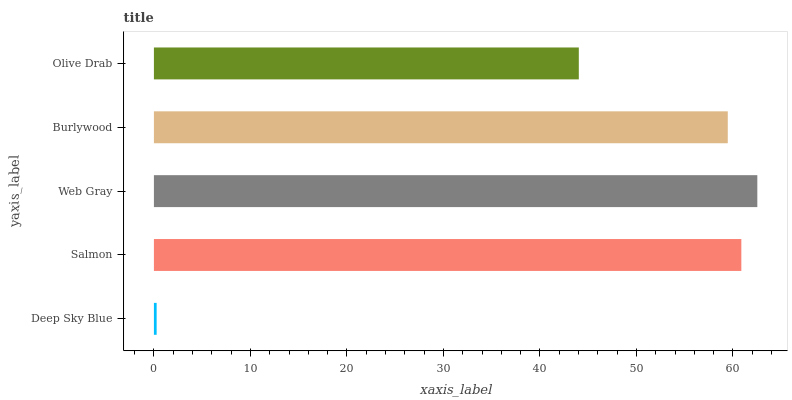Is Deep Sky Blue the minimum?
Answer yes or no. Yes. Is Web Gray the maximum?
Answer yes or no. Yes. Is Salmon the minimum?
Answer yes or no. No. Is Salmon the maximum?
Answer yes or no. No. Is Salmon greater than Deep Sky Blue?
Answer yes or no. Yes. Is Deep Sky Blue less than Salmon?
Answer yes or no. Yes. Is Deep Sky Blue greater than Salmon?
Answer yes or no. No. Is Salmon less than Deep Sky Blue?
Answer yes or no. No. Is Burlywood the high median?
Answer yes or no. Yes. Is Burlywood the low median?
Answer yes or no. Yes. Is Salmon the high median?
Answer yes or no. No. Is Web Gray the low median?
Answer yes or no. No. 